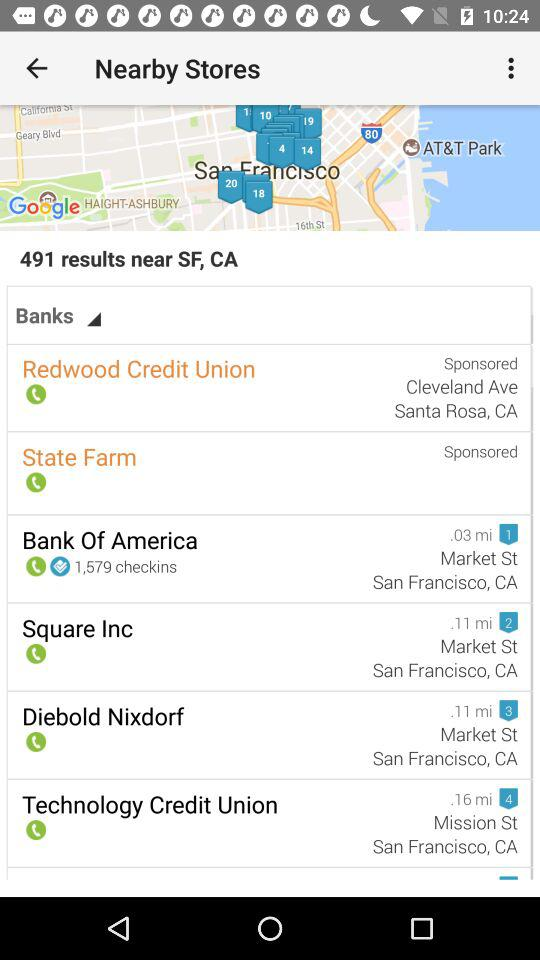How far is Bank of America? The Bank of America is 0.03 miles away. 